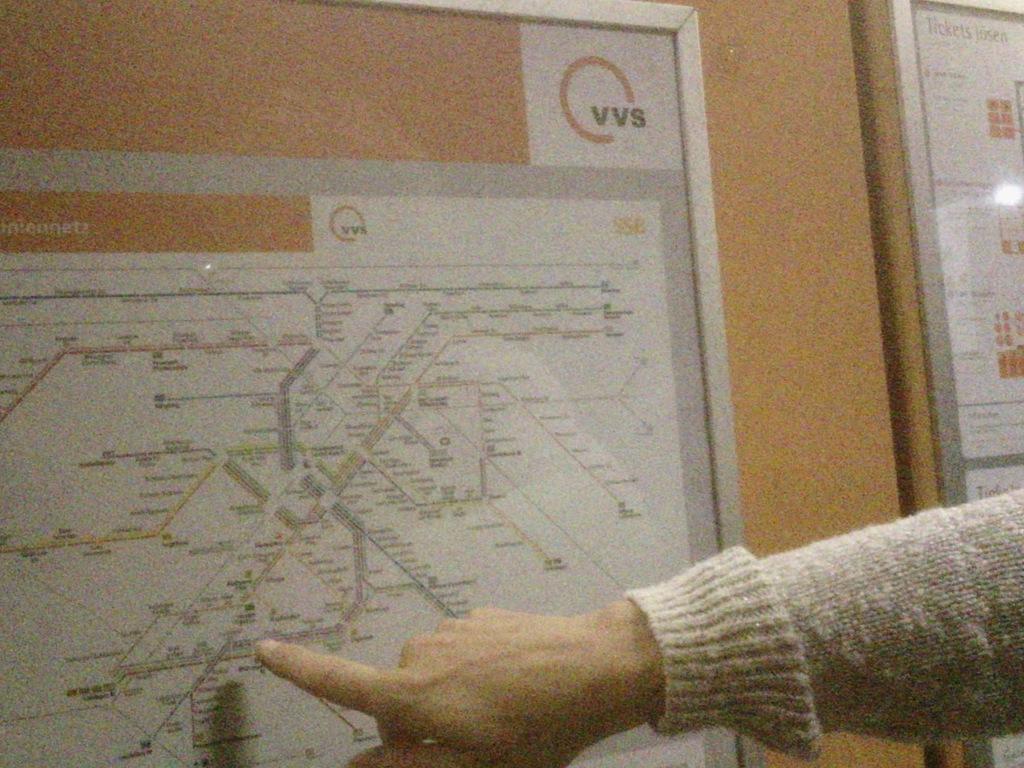Can you describe this image briefly? In this image we can see a map on the wall. There is a person's hand. 